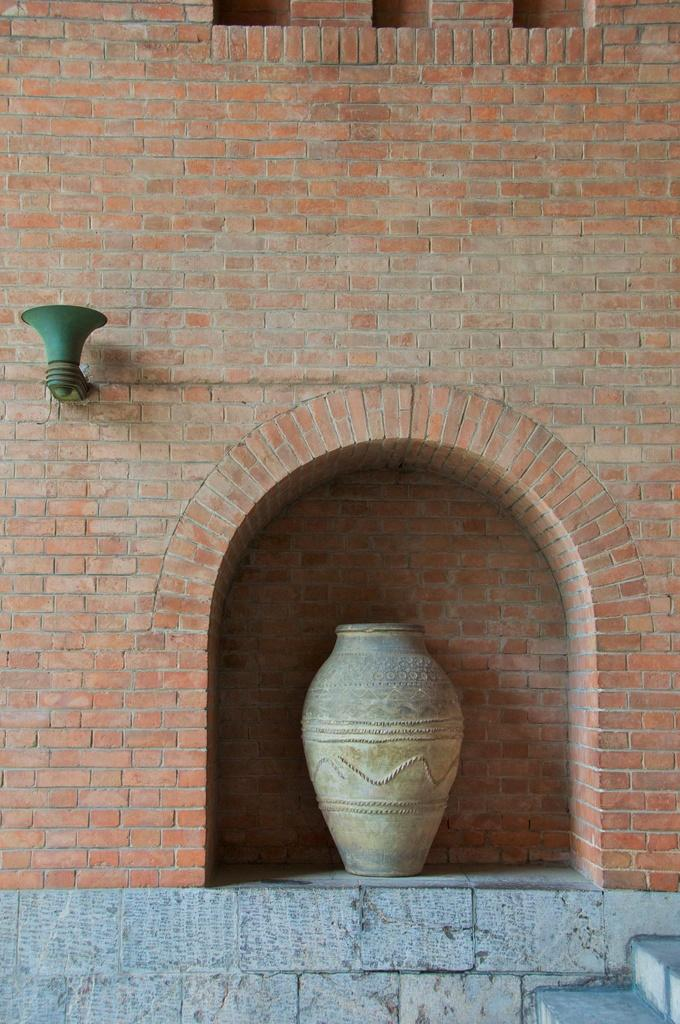What object is present in the image that is typically used for cooking or storage? There is a pot in the image. What is the source of illumination in the image? There is a light in the image. What architectural feature is present in the image that allows for vertical movement between different levels? There are stairs in the image. What type of structure is present in the image that serves as a barrier or divider? There is a wall in the image. How does the pot swim in the image? The pot does not swim in the image; it is stationary and not in water. What type of power source is used to operate the light in the image? The facts provided do not specify the type of power source used for the light in the image. Where is the parcel located in the image? There is no mention of a parcel in the provided facts, so it cannot be determined from the image. 